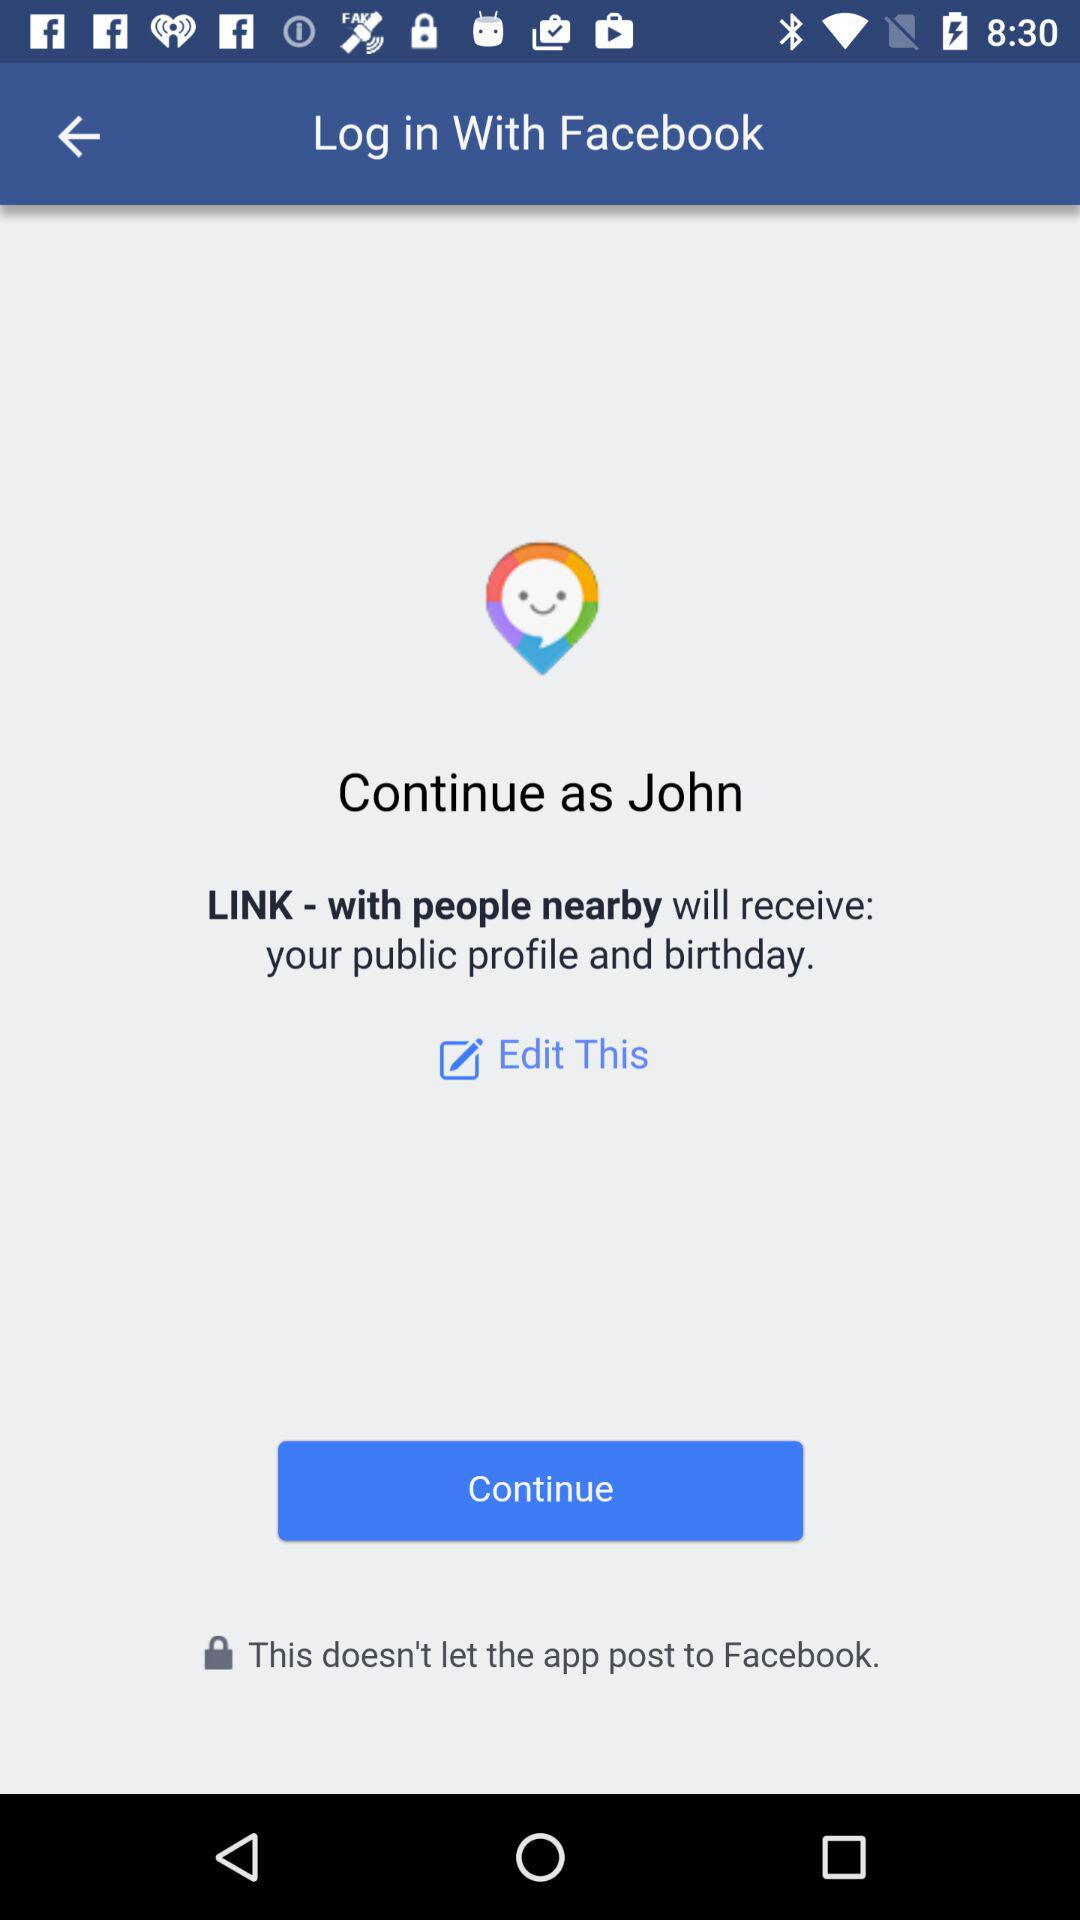Who will receive your public profile and birthday? Your public profile and birthday will be received by "LINK - with people nearby". 